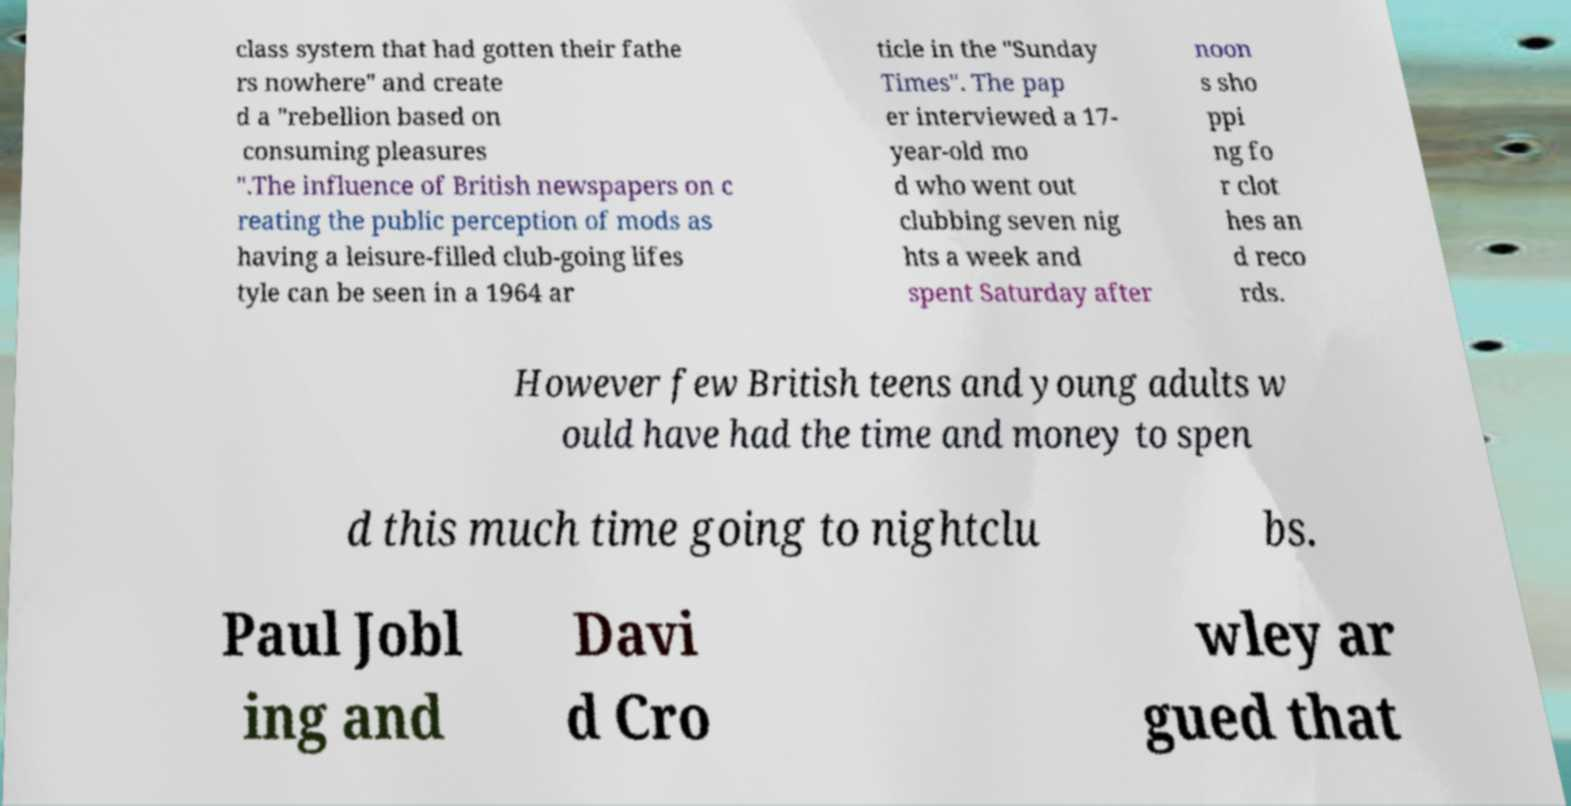Could you extract and type out the text from this image? class system that had gotten their fathe rs nowhere" and create d a "rebellion based on consuming pleasures ".The influence of British newspapers on c reating the public perception of mods as having a leisure-filled club-going lifes tyle can be seen in a 1964 ar ticle in the "Sunday Times". The pap er interviewed a 17- year-old mo d who went out clubbing seven nig hts a week and spent Saturday after noon s sho ppi ng fo r clot hes an d reco rds. However few British teens and young adults w ould have had the time and money to spen d this much time going to nightclu bs. Paul Jobl ing and Davi d Cro wley ar gued that 